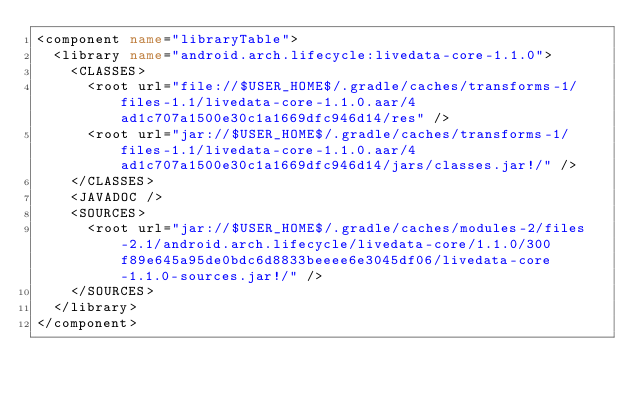<code> <loc_0><loc_0><loc_500><loc_500><_XML_><component name="libraryTable">
  <library name="android.arch.lifecycle:livedata-core-1.1.0">
    <CLASSES>
      <root url="file://$USER_HOME$/.gradle/caches/transforms-1/files-1.1/livedata-core-1.1.0.aar/4ad1c707a1500e30c1a1669dfc946d14/res" />
      <root url="jar://$USER_HOME$/.gradle/caches/transforms-1/files-1.1/livedata-core-1.1.0.aar/4ad1c707a1500e30c1a1669dfc946d14/jars/classes.jar!/" />
    </CLASSES>
    <JAVADOC />
    <SOURCES>
      <root url="jar://$USER_HOME$/.gradle/caches/modules-2/files-2.1/android.arch.lifecycle/livedata-core/1.1.0/300f89e645a95de0bdc6d8833beeee6e3045df06/livedata-core-1.1.0-sources.jar!/" />
    </SOURCES>
  </library>
</component></code> 